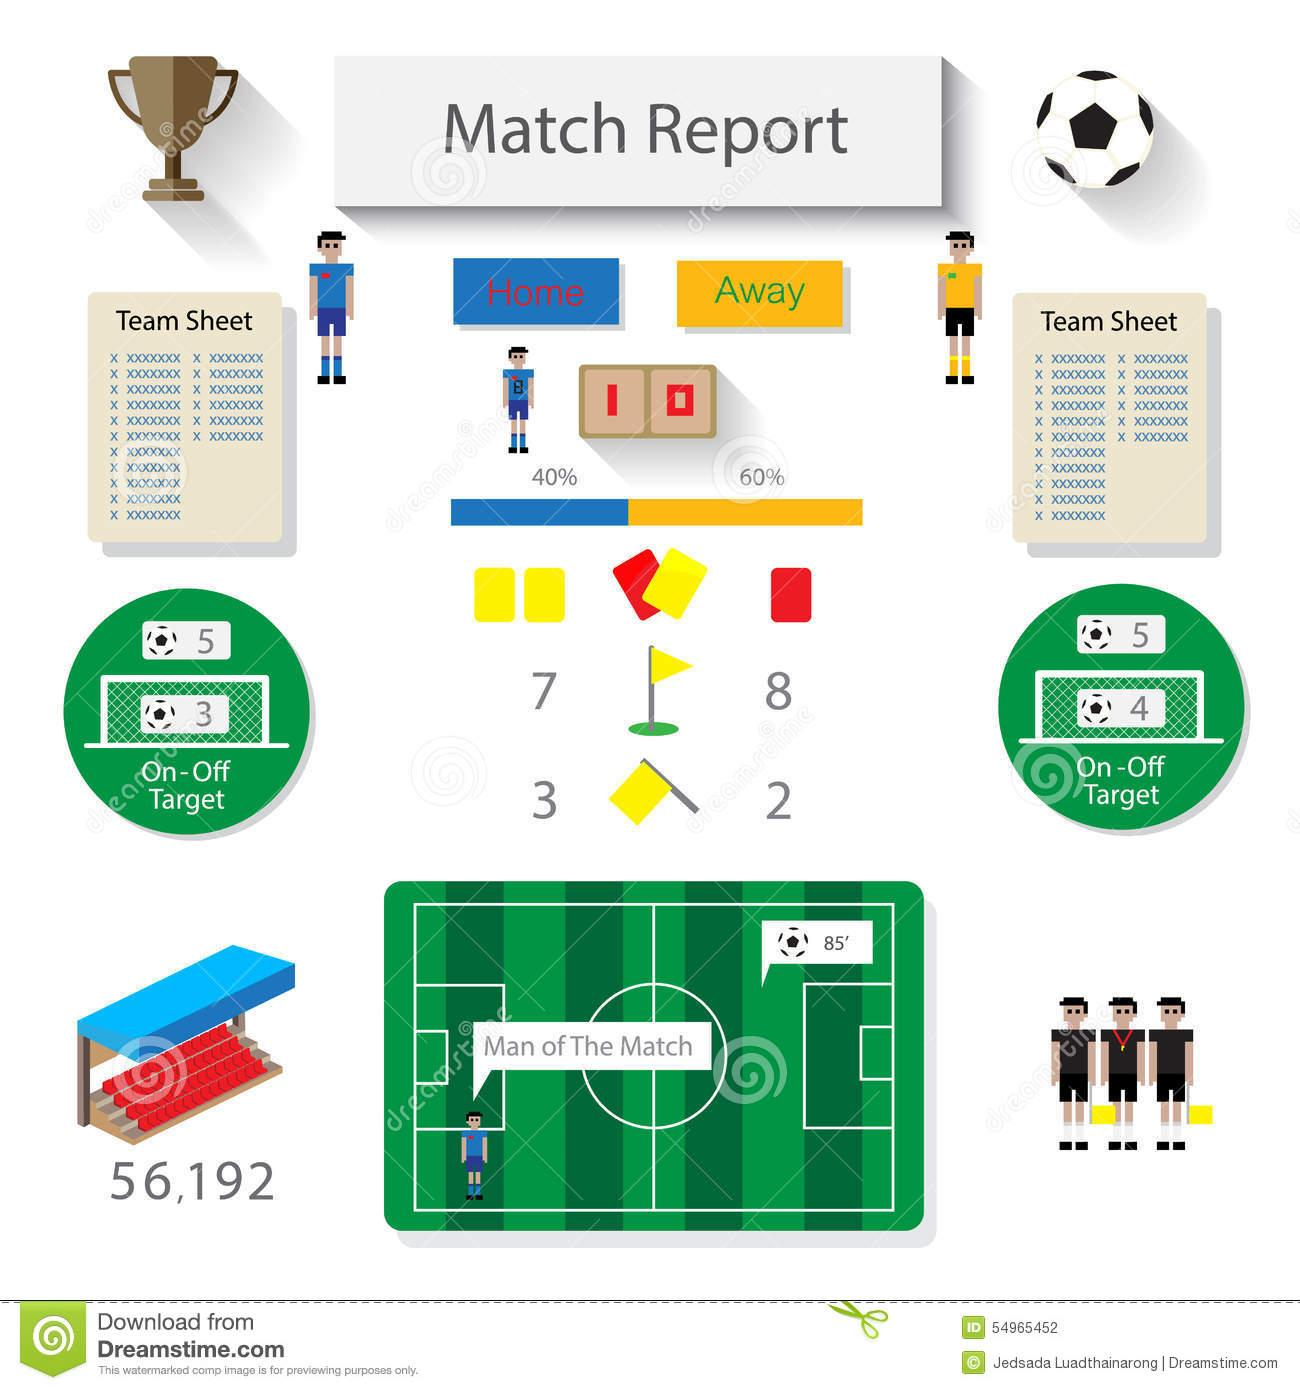Highlight a few significant elements in this photo. The color of the jersey of the away team is yellow, and its color is also red, green, and blue. The away team has 60% possession of the ball. Out of the three attempts by the home team, two were on target. In the game, the away team did not score any goals. The match was won by the home team. 